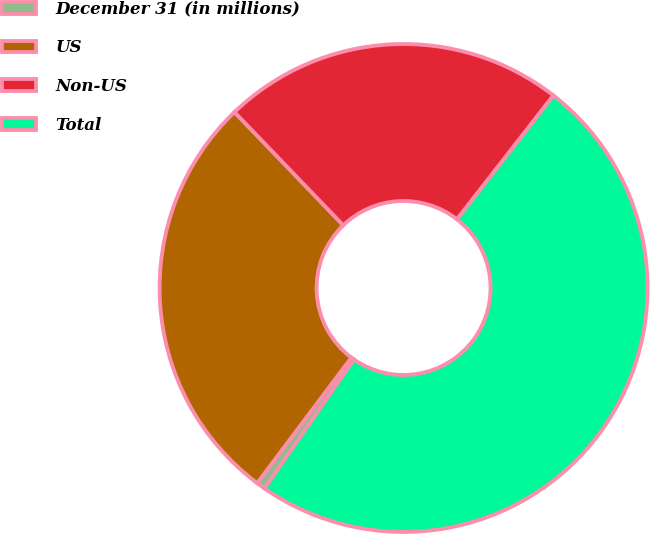Convert chart. <chart><loc_0><loc_0><loc_500><loc_500><pie_chart><fcel>December 31 (in millions)<fcel>US<fcel>Non-US<fcel>Total<nl><fcel>0.59%<fcel>27.57%<fcel>22.72%<fcel>49.13%<nl></chart> 